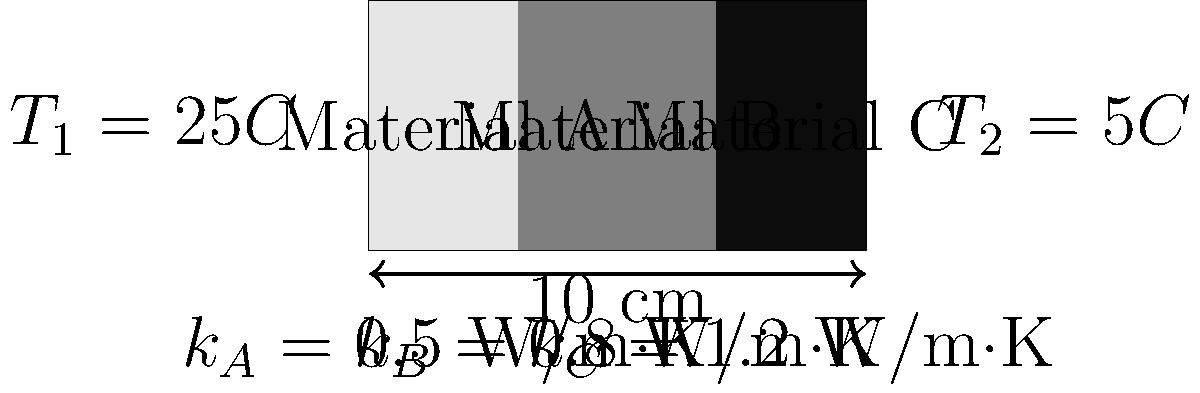A composite wall consists of three layers of different materials (A, B, and C) with thermal conductivities $k_A = 0.5$ W/m·K, $k_B = 0.8$ W/m·K, and $k_C = 1.2$ W/m·K, respectively. The wall has a total thickness of 10 cm, with Material A being 3 cm thick, Material B 4 cm thick, and Material C 3 cm thick. If the temperature on the left side of the wall is 25°C and on the right side is 5°C, calculate the temperature at the interface between Materials A and B. To solve this problem, we'll use the concept of thermal resistance in series and the fact that the heat flux is constant across all layers in steady-state conditions.

Step 1: Calculate the total thermal resistance of the wall.
$R_{total} = R_A + R_B + R_C$
$R_i = \frac{L_i}{k_i}$, where $L_i$ is the thickness of layer $i$

$R_A = \frac{0.03}{0.5} = 0.06$ m²·K/W
$R_B = \frac{0.04}{0.8} = 0.05$ m²·K/W
$R_C = \frac{0.03}{1.2} = 0.025$ m²·K/W

$R_{total} = 0.06 + 0.05 + 0.025 = 0.135$ m²·K/W

Step 2: Calculate the heat flux through the wall.
$q = \frac{T_1 - T_2}{R_{total}} = \frac{25 - 5}{0.135} = 148.15$ W/m²

Step 3: Calculate the temperature drop across Material A.
$\Delta T_A = q \cdot R_A = 148.15 \cdot 0.06 = 8.89°C$

Step 4: Calculate the temperature at the interface between Materials A and B.
$T_{interface} = T_1 - \Delta T_A = 25 - 8.89 = 16.11°C$
Answer: 16.11°C 